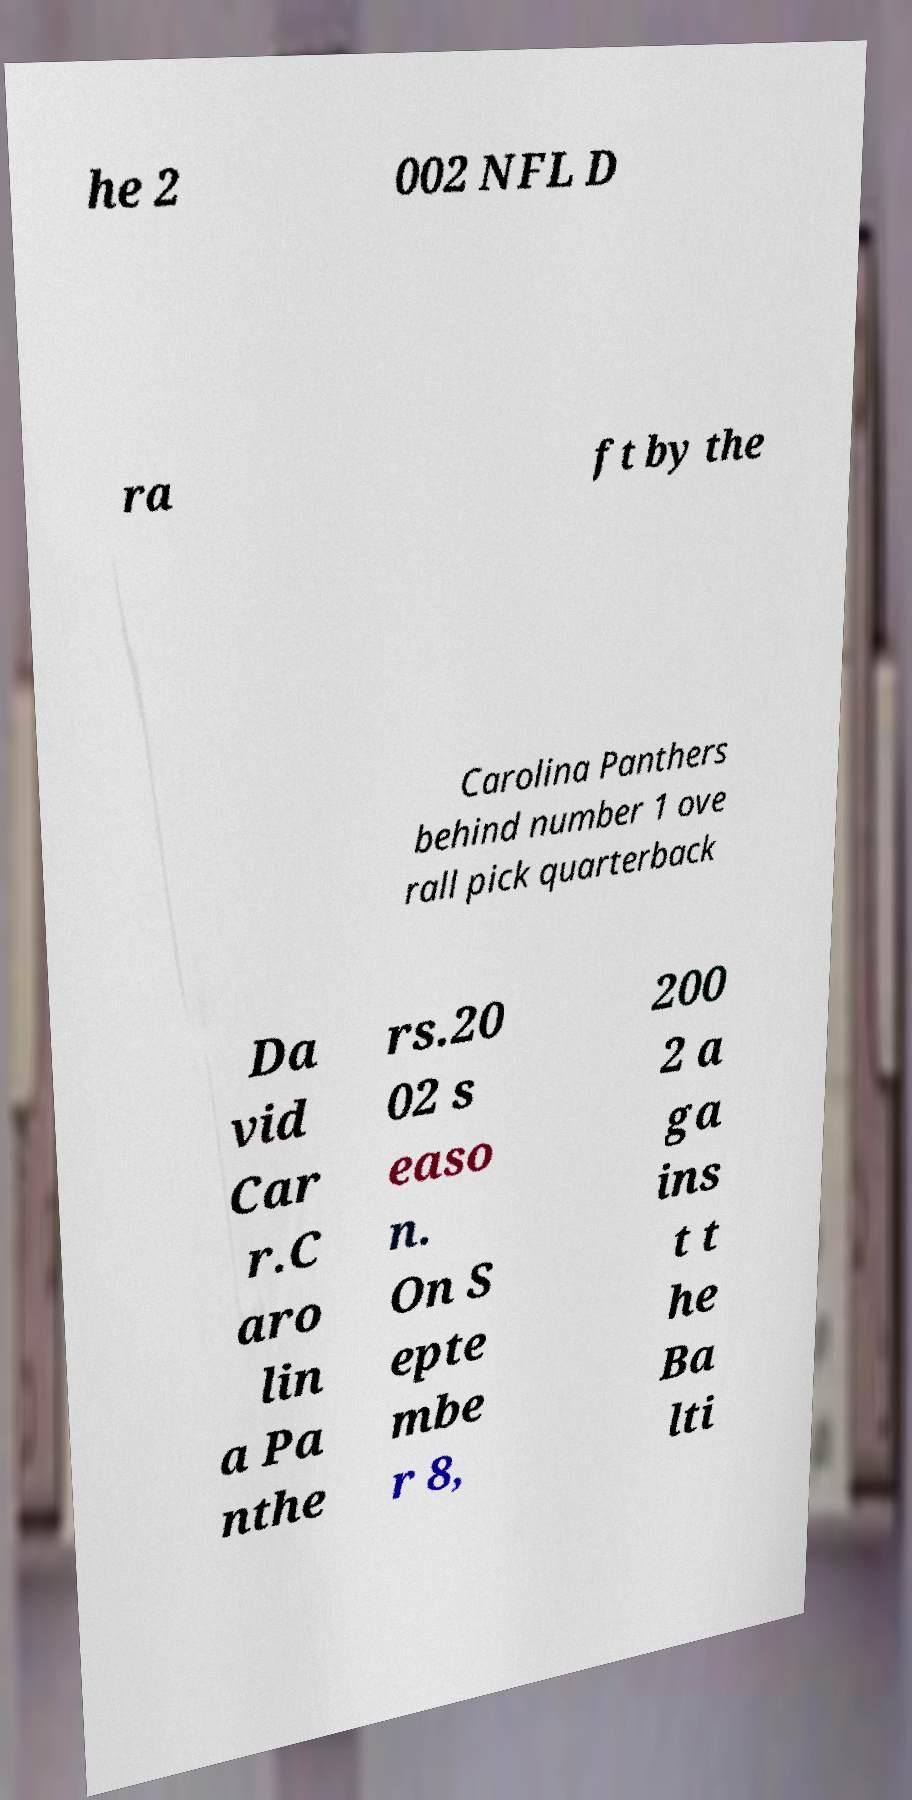Could you assist in decoding the text presented in this image and type it out clearly? he 2 002 NFL D ra ft by the Carolina Panthers behind number 1 ove rall pick quarterback Da vid Car r.C aro lin a Pa nthe rs.20 02 s easo n. On S epte mbe r 8, 200 2 a ga ins t t he Ba lti 